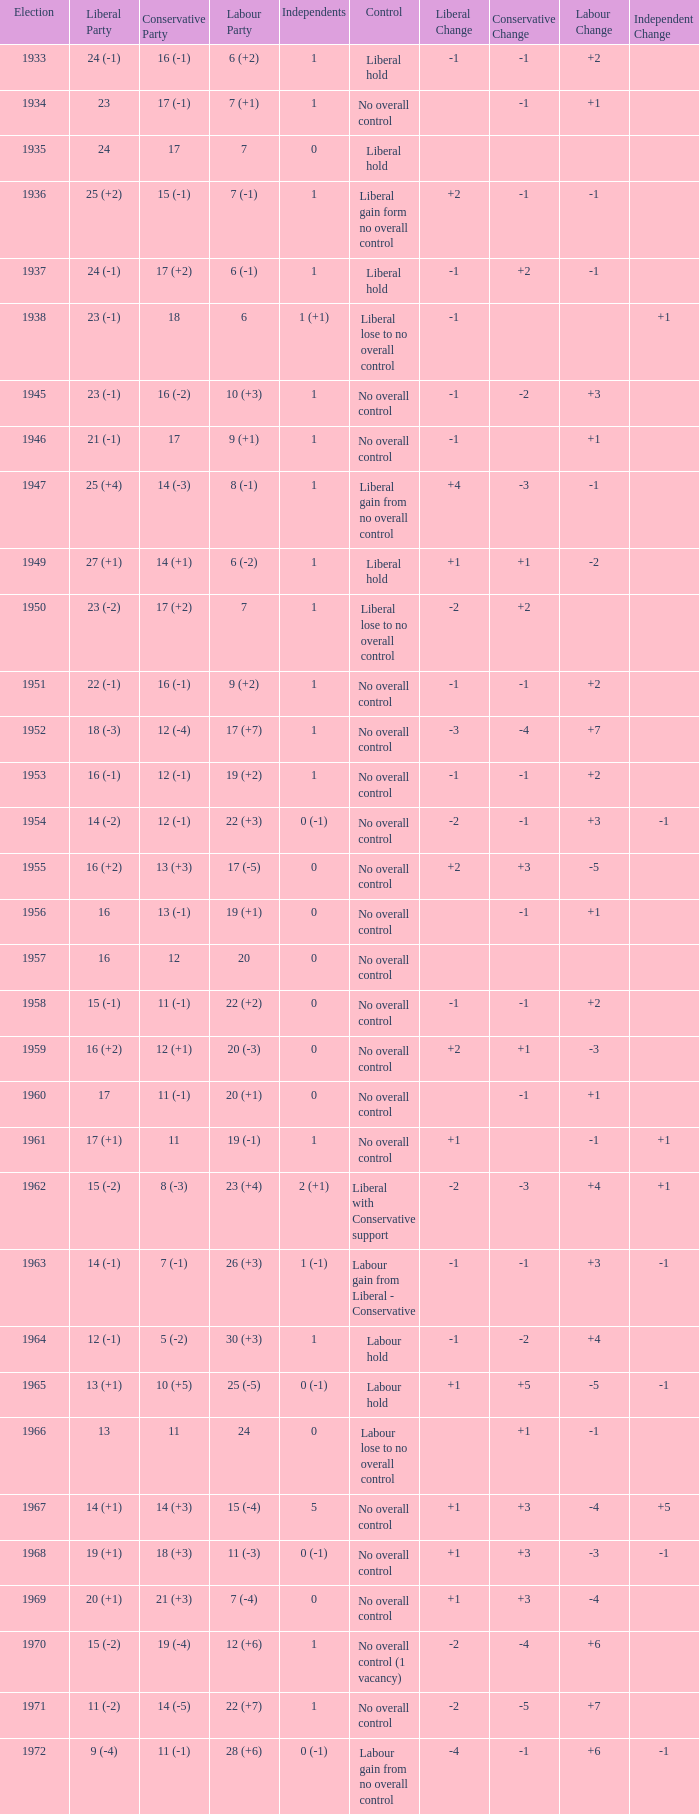Could you parse the entire table? {'header': ['Election', 'Liberal Party', 'Conservative Party', 'Labour Party', 'Independents', 'Control', 'Liberal Change', 'Conservative Change', 'Labour Change', 'Independent Change'], 'rows': [['1933', '24 (-1)', '16 (-1)', '6 (+2)', '1', 'Liberal hold', '-1', '-1', '+2', ''], ['1934', '23', '17 (-1)', '7 (+1)', '1', 'No overall control', '', '-1', '+1', ''], ['1935', '24', '17', '7', '0', 'Liberal hold', '', '', '', ''], ['1936', '25 (+2)', '15 (-1)', '7 (-1)', '1', 'Liberal gain form no overall control', '+2', '-1', '-1', ''], ['1937', '24 (-1)', '17 (+2)', '6 (-1)', '1', 'Liberal hold', '-1', '+2', '-1', ''], ['1938', '23 (-1)', '18', '6', '1 (+1)', 'Liberal lose to no overall control', '-1', '', '', '+1'], ['1945', '23 (-1)', '16 (-2)', '10 (+3)', '1', 'No overall control', '-1', '-2', '+3', ''], ['1946', '21 (-1)', '17', '9 (+1)', '1', 'No overall control', '-1', '', '+1', ''], ['1947', '25 (+4)', '14 (-3)', '8 (-1)', '1', 'Liberal gain from no overall control', '+4', '-3', '-1', ''], ['1949', '27 (+1)', '14 (+1)', '6 (-2)', '1', 'Liberal hold', '+1', '+1', '-2', ''], ['1950', '23 (-2)', '17 (+2)', '7', '1', 'Liberal lose to no overall control', '-2', '+2', '', ''], ['1951', '22 (-1)', '16 (-1)', '9 (+2)', '1', 'No overall control', '-1', '-1', '+2', ''], ['1952', '18 (-3)', '12 (-4)', '17 (+7)', '1', 'No overall control', '-3', '-4', '+7', ''], ['1953', '16 (-1)', '12 (-1)', '19 (+2)', '1', 'No overall control', '-1', '-1', '+2', ''], ['1954', '14 (-2)', '12 (-1)', '22 (+3)', '0 (-1)', 'No overall control', '-2', '-1', '+3', '-1'], ['1955', '16 (+2)', '13 (+3)', '17 (-5)', '0', 'No overall control', '+2', '+3', '-5', ''], ['1956', '16', '13 (-1)', '19 (+1)', '0', 'No overall control', '', '-1', '+1', ''], ['1957', '16', '12', '20', '0', 'No overall control', '', '', '', ''], ['1958', '15 (-1)', '11 (-1)', '22 (+2)', '0', 'No overall control', '-1', '-1', '+2', ''], ['1959', '16 (+2)', '12 (+1)', '20 (-3)', '0', 'No overall control', '+2', '+1', '-3', ''], ['1960', '17', '11 (-1)', '20 (+1)', '0', 'No overall control', '', '-1', '+1', ''], ['1961', '17 (+1)', '11', '19 (-1)', '1', 'No overall control', '+1', '', '-1', '+1'], ['1962', '15 (-2)', '8 (-3)', '23 (+4)', '2 (+1)', 'Liberal with Conservative support', '-2', '-3', '+4', '+1'], ['1963', '14 (-1)', '7 (-1)', '26 (+3)', '1 (-1)', 'Labour gain from Liberal - Conservative', '-1', '-1', '+3', '-1'], ['1964', '12 (-1)', '5 (-2)', '30 (+3)', '1', 'Labour hold', '-1', '-2', '+4', ''], ['1965', '13 (+1)', '10 (+5)', '25 (-5)', '0 (-1)', 'Labour hold', '+1', '+5', '-5', '-1'], ['1966', '13', '11', '24', '0', 'Labour lose to no overall control', '', '+1', '-1', ''], ['1967', '14 (+1)', '14 (+3)', '15 (-4)', '5', 'No overall control', '+1', '+3', '-4', '+5'], ['1968', '19 (+1)', '18 (+3)', '11 (-3)', '0 (-1)', 'No overall control', '+1', '+3', '-3', '-1'], ['1969', '20 (+1)', '21 (+3)', '7 (-4)', '0', 'No overall control', '+1', '+3', '-4', ''], ['1970', '15 (-2)', '19 (-4)', '12 (+6)', '1', 'No overall control (1 vacancy)', '-2', '-4', '+6', ''], ['1971', '11 (-2)', '14 (-5)', '22 (+7)', '1', 'No overall control', '-2', '-5', '+7', ''], ['1972', '9 (-4)', '11 (-1)', '28 (+6)', '0 (-1)', 'Labour gain from no overall control', '-4', '-1', '+6', '-1']]} What is the number of Independents elected in the year Labour won 26 (+3) seats? 1 (-1). 